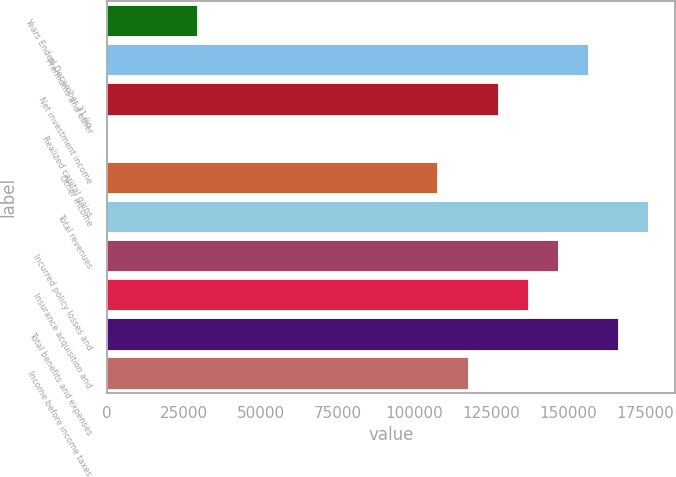Convert chart to OTSL. <chart><loc_0><loc_0><loc_500><loc_500><bar_chart><fcel>Years Ended December 31 (in<fcel>Premiums and other<fcel>Net investment income<fcel>Realized capital gains<fcel>Other income<fcel>Total revenues<fcel>Incurred policy losses and<fcel>Insurance acquisition and<fcel>Total benefits and expenses<fcel>Income before income taxes<nl><fcel>29330.6<fcel>156239<fcel>126953<fcel>44<fcel>107428<fcel>175764<fcel>146477<fcel>136715<fcel>166001<fcel>117190<nl></chart> 